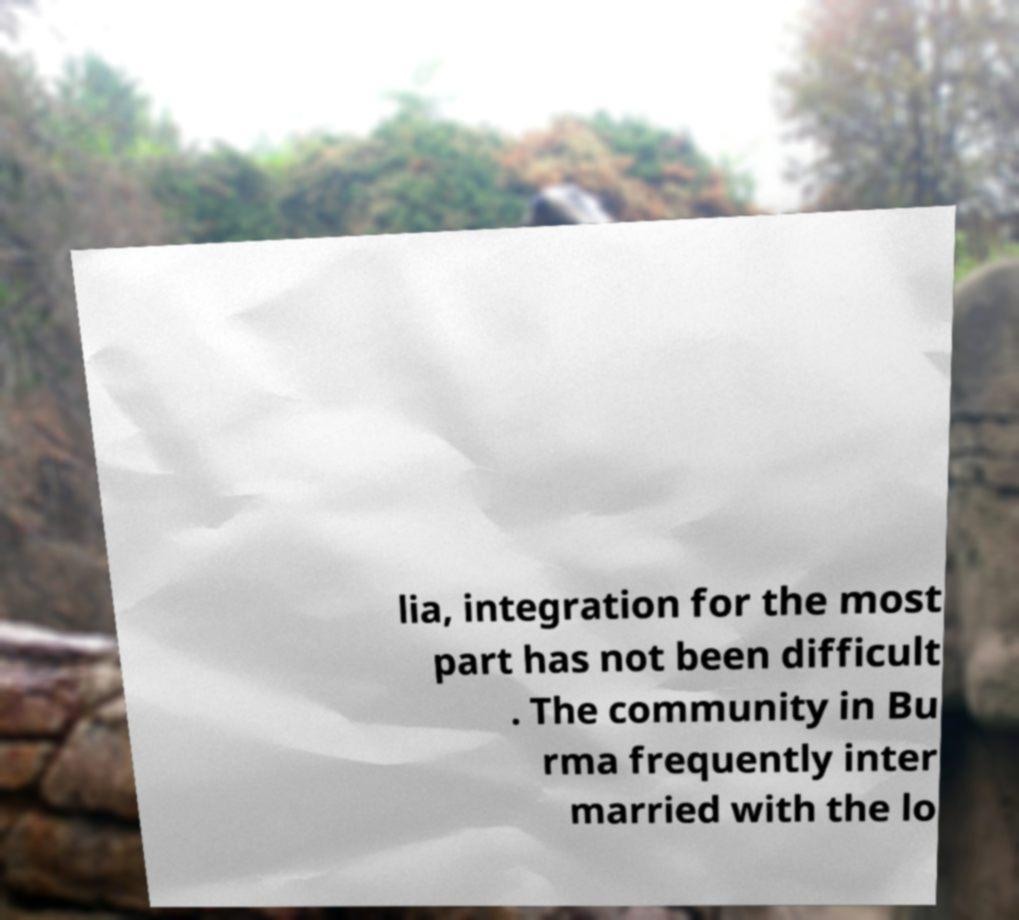Please identify and transcribe the text found in this image. lia, integration for the most part has not been difficult . The community in Bu rma frequently inter married with the lo 